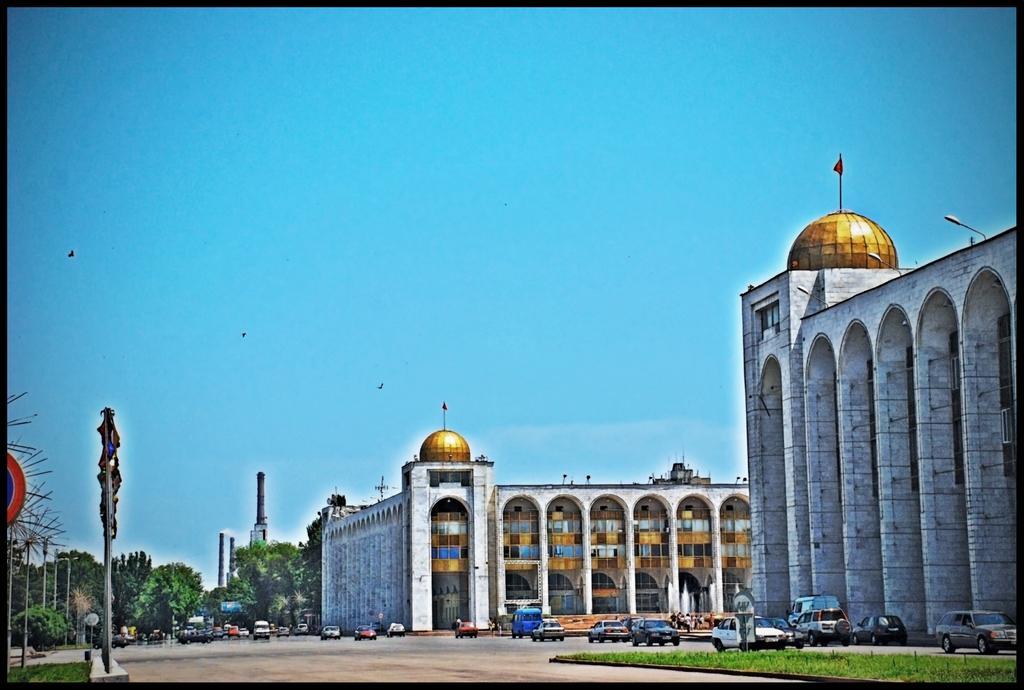Can you describe this image briefly? In this image, we can see buildings. There are cars on the road. There are poles and some trees in the bottom left of the image. In the background of the image, there is a sky. 